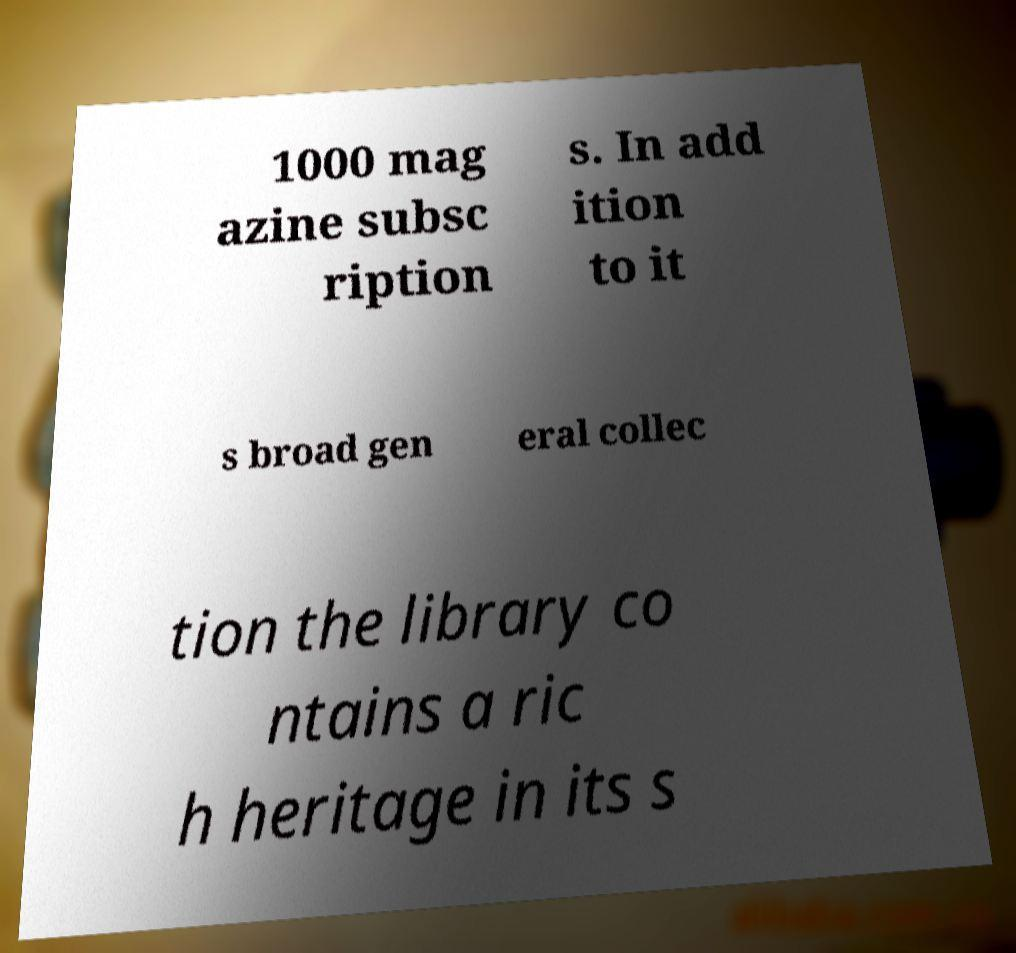For documentation purposes, I need the text within this image transcribed. Could you provide that? 1000 mag azine subsc ription s. In add ition to it s broad gen eral collec tion the library co ntains a ric h heritage in its s 